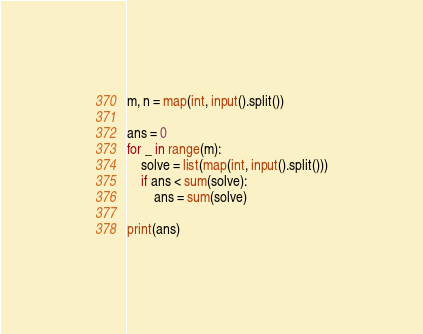Convert code to text. <code><loc_0><loc_0><loc_500><loc_500><_Python_>m, n = map(int, input().split())

ans = 0
for _ in range(m):
    solve = list(map(int, input().split()))
    if ans < sum(solve):
        ans = sum(solve)

print(ans)

</code> 